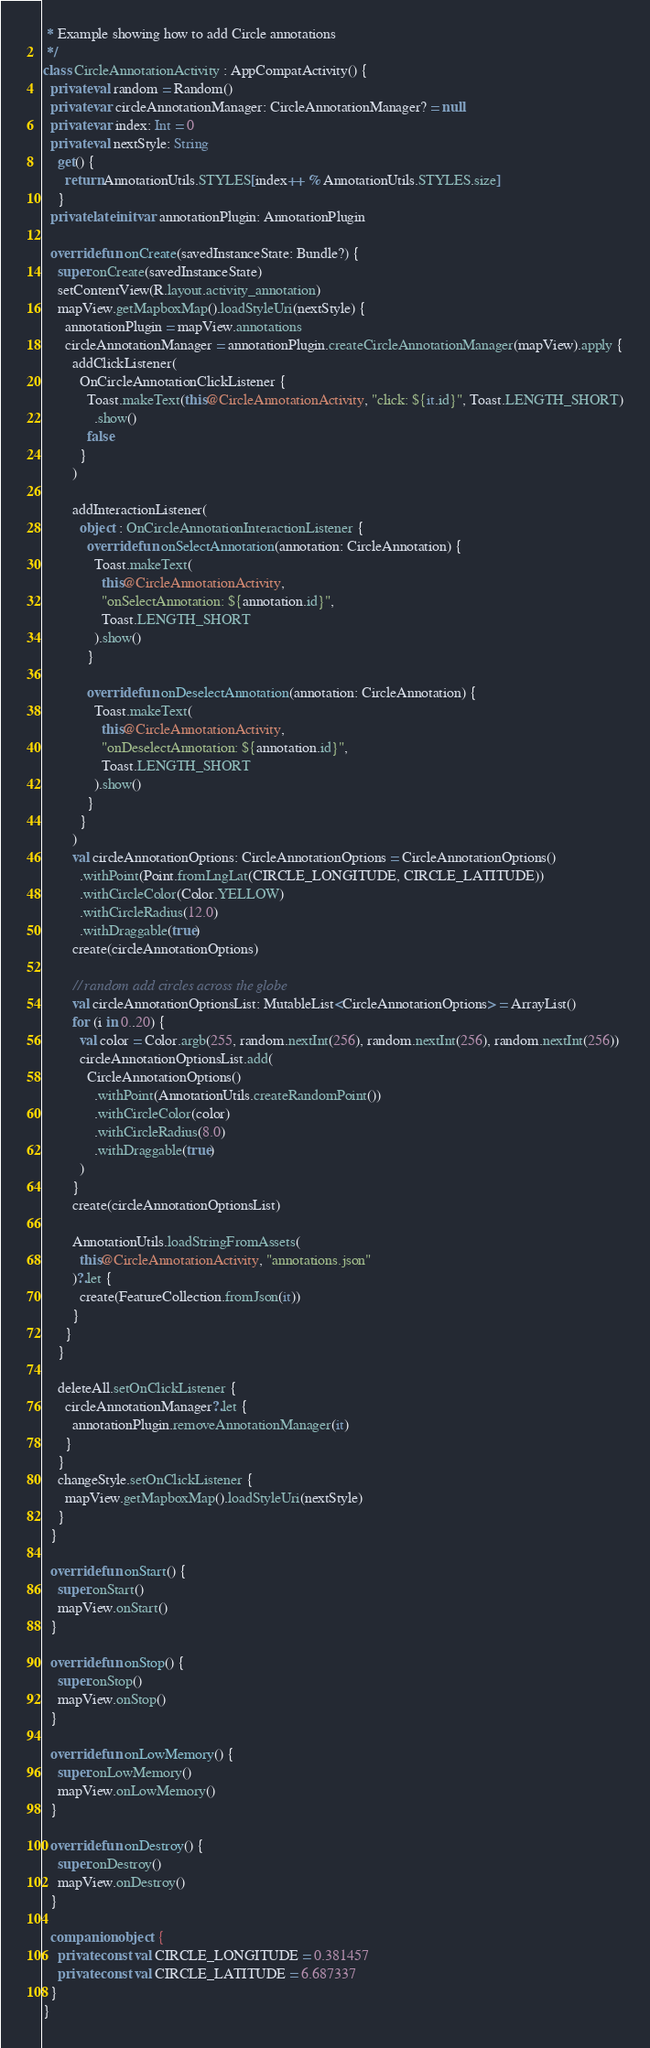Convert code to text. <code><loc_0><loc_0><loc_500><loc_500><_Kotlin_> * Example showing how to add Circle annotations
 */
class CircleAnnotationActivity : AppCompatActivity() {
  private val random = Random()
  private var circleAnnotationManager: CircleAnnotationManager? = null
  private var index: Int = 0
  private val nextStyle: String
    get() {
      return AnnotationUtils.STYLES[index++ % AnnotationUtils.STYLES.size]
    }
  private lateinit var annotationPlugin: AnnotationPlugin

  override fun onCreate(savedInstanceState: Bundle?) {
    super.onCreate(savedInstanceState)
    setContentView(R.layout.activity_annotation)
    mapView.getMapboxMap().loadStyleUri(nextStyle) {
      annotationPlugin = mapView.annotations
      circleAnnotationManager = annotationPlugin.createCircleAnnotationManager(mapView).apply {
        addClickListener(
          OnCircleAnnotationClickListener {
            Toast.makeText(this@CircleAnnotationActivity, "click: ${it.id}", Toast.LENGTH_SHORT)
              .show()
            false
          }
        )

        addInteractionListener(
          object : OnCircleAnnotationInteractionListener {
            override fun onSelectAnnotation(annotation: CircleAnnotation) {
              Toast.makeText(
                this@CircleAnnotationActivity,
                "onSelectAnnotation: ${annotation.id}",
                Toast.LENGTH_SHORT
              ).show()
            }

            override fun onDeselectAnnotation(annotation: CircleAnnotation) {
              Toast.makeText(
                this@CircleAnnotationActivity,
                "onDeselectAnnotation: ${annotation.id}",
                Toast.LENGTH_SHORT
              ).show()
            }
          }
        )
        val circleAnnotationOptions: CircleAnnotationOptions = CircleAnnotationOptions()
          .withPoint(Point.fromLngLat(CIRCLE_LONGITUDE, CIRCLE_LATITUDE))
          .withCircleColor(Color.YELLOW)
          .withCircleRadius(12.0)
          .withDraggable(true)
        create(circleAnnotationOptions)

        // random add circles across the globe
        val circleAnnotationOptionsList: MutableList<CircleAnnotationOptions> = ArrayList()
        for (i in 0..20) {
          val color = Color.argb(255, random.nextInt(256), random.nextInt(256), random.nextInt(256))
          circleAnnotationOptionsList.add(
            CircleAnnotationOptions()
              .withPoint(AnnotationUtils.createRandomPoint())
              .withCircleColor(color)
              .withCircleRadius(8.0)
              .withDraggable(true)
          )
        }
        create(circleAnnotationOptionsList)

        AnnotationUtils.loadStringFromAssets(
          this@CircleAnnotationActivity, "annotations.json"
        )?.let {
          create(FeatureCollection.fromJson(it))
        }
      }
    }

    deleteAll.setOnClickListener {
      circleAnnotationManager?.let {
        annotationPlugin.removeAnnotationManager(it)
      }
    }
    changeStyle.setOnClickListener {
      mapView.getMapboxMap().loadStyleUri(nextStyle)
    }
  }

  override fun onStart() {
    super.onStart()
    mapView.onStart()
  }

  override fun onStop() {
    super.onStop()
    mapView.onStop()
  }

  override fun onLowMemory() {
    super.onLowMemory()
    mapView.onLowMemory()
  }

  override fun onDestroy() {
    super.onDestroy()
    mapView.onDestroy()
  }

  companion object {
    private const val CIRCLE_LONGITUDE = 0.381457
    private const val CIRCLE_LATITUDE = 6.687337
  }
}</code> 